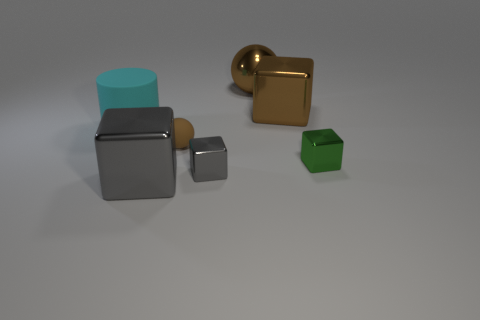What materials do the objects in the image appear to be made of? The objects in the image feature surfaces that resemble common materials: the cubes and spheres appear to be metallic, given their lustrous sheen which reflects the environment, while the more matte surfaced cube might suggest a type of plastic or painted metal. 